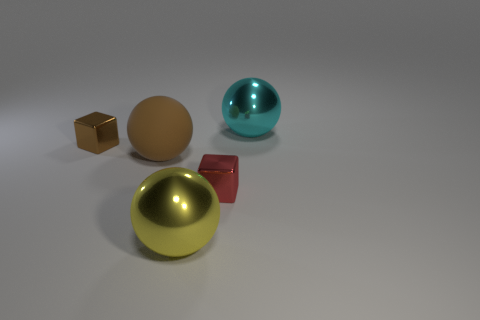What shape is the tiny object that is the same color as the big matte thing?
Ensure brevity in your answer.  Cube. What material is the small brown block?
Make the answer very short. Metal. Do the brown object to the right of the brown metal object and the cube that is on the left side of the large yellow ball have the same size?
Offer a very short reply. No. How many other objects are the same size as the cyan object?
Provide a succinct answer. 2. What number of things are large metallic things that are behind the large yellow shiny thing or cyan spheres right of the matte thing?
Offer a very short reply. 1. Is the material of the small brown cube the same as the brown thing that is in front of the small brown block?
Keep it short and to the point. No. How many other objects are there of the same shape as the brown rubber object?
Ensure brevity in your answer.  2. What material is the large sphere that is right of the cube in front of the small shiny block that is to the left of the yellow metal object made of?
Your answer should be very brief. Metal. Are there the same number of metal cubes that are in front of the big brown ball and big yellow balls?
Your response must be concise. Yes. Do the small red block to the left of the large cyan shiny sphere and the ball that is to the right of the yellow ball have the same material?
Provide a short and direct response. Yes. 